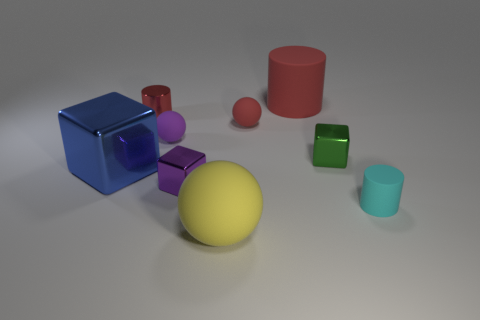Add 1 big cubes. How many objects exist? 10 Subtract all blocks. How many objects are left? 6 Subtract all big red matte things. Subtract all cyan things. How many objects are left? 7 Add 7 big yellow spheres. How many big yellow spheres are left? 8 Add 6 purple blocks. How many purple blocks exist? 7 Subtract 0 blue cylinders. How many objects are left? 9 